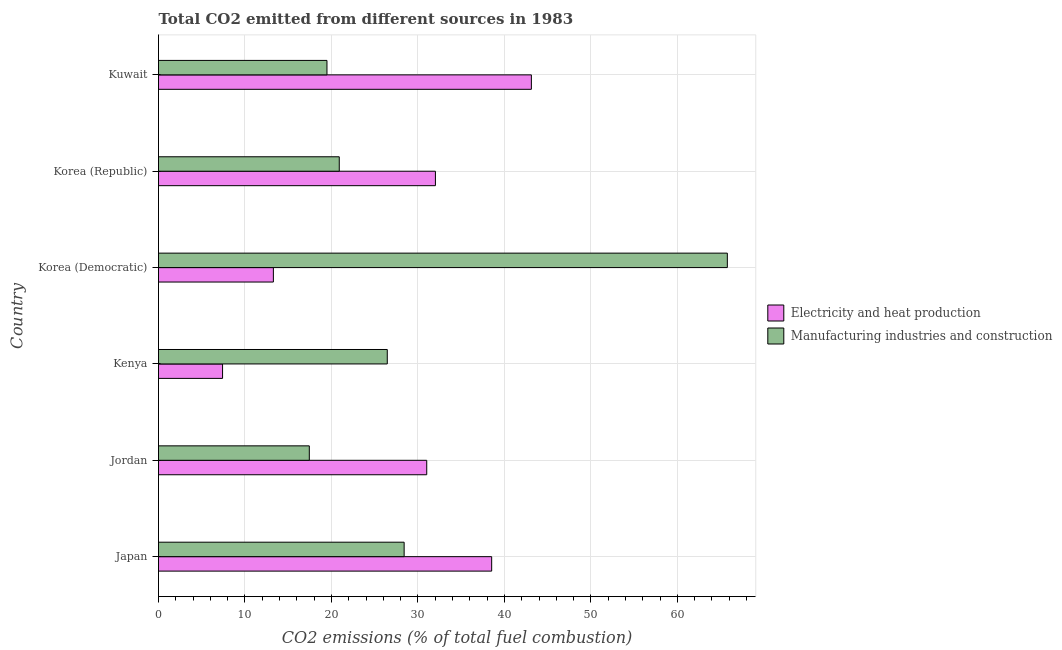Are the number of bars per tick equal to the number of legend labels?
Your response must be concise. Yes. Are the number of bars on each tick of the Y-axis equal?
Your answer should be compact. Yes. How many bars are there on the 5th tick from the top?
Your response must be concise. 2. What is the label of the 1st group of bars from the top?
Your response must be concise. Kuwait. In how many cases, is the number of bars for a given country not equal to the number of legend labels?
Offer a very short reply. 0. What is the co2 emissions due to manufacturing industries in Korea (Republic)?
Your answer should be compact. 20.9. Across all countries, what is the maximum co2 emissions due to electricity and heat production?
Your response must be concise. 43.12. Across all countries, what is the minimum co2 emissions due to electricity and heat production?
Your answer should be very brief. 7.41. In which country was the co2 emissions due to electricity and heat production maximum?
Your answer should be very brief. Kuwait. In which country was the co2 emissions due to electricity and heat production minimum?
Your response must be concise. Kenya. What is the total co2 emissions due to manufacturing industries in the graph?
Offer a very short reply. 178.46. What is the difference between the co2 emissions due to electricity and heat production in Jordan and that in Kuwait?
Your answer should be compact. -12.1. What is the difference between the co2 emissions due to electricity and heat production in Japan and the co2 emissions due to manufacturing industries in Korea (Democratic)?
Offer a very short reply. -27.25. What is the average co2 emissions due to electricity and heat production per country?
Provide a succinct answer. 27.56. What is the difference between the co2 emissions due to manufacturing industries and co2 emissions due to electricity and heat production in Korea (Republic)?
Make the answer very short. -11.12. What is the ratio of the co2 emissions due to electricity and heat production in Kenya to that in Korea (Republic)?
Provide a succinct answer. 0.23. Is the co2 emissions due to manufacturing industries in Korea (Republic) less than that in Kuwait?
Offer a terse response. No. Is the difference between the co2 emissions due to electricity and heat production in Japan and Kuwait greater than the difference between the co2 emissions due to manufacturing industries in Japan and Kuwait?
Offer a very short reply. No. What is the difference between the highest and the second highest co2 emissions due to manufacturing industries?
Offer a terse response. 37.38. What is the difference between the highest and the lowest co2 emissions due to manufacturing industries?
Give a very brief answer. 48.34. What does the 1st bar from the top in Kenya represents?
Your response must be concise. Manufacturing industries and construction. What does the 2nd bar from the bottom in Korea (Republic) represents?
Give a very brief answer. Manufacturing industries and construction. How many bars are there?
Your answer should be compact. 12. Are all the bars in the graph horizontal?
Provide a short and direct response. Yes. What is the difference between two consecutive major ticks on the X-axis?
Your answer should be very brief. 10. Are the values on the major ticks of X-axis written in scientific E-notation?
Your response must be concise. No. Where does the legend appear in the graph?
Your answer should be very brief. Center right. How many legend labels are there?
Your answer should be compact. 2. How are the legend labels stacked?
Offer a very short reply. Vertical. What is the title of the graph?
Provide a succinct answer. Total CO2 emitted from different sources in 1983. What is the label or title of the X-axis?
Your response must be concise. CO2 emissions (% of total fuel combustion). What is the CO2 emissions (% of total fuel combustion) of Electricity and heat production in Japan?
Keep it short and to the point. 38.53. What is the CO2 emissions (% of total fuel combustion) of Manufacturing industries and construction in Japan?
Your answer should be compact. 28.41. What is the CO2 emissions (% of total fuel combustion) in Electricity and heat production in Jordan?
Offer a terse response. 31.02. What is the CO2 emissions (% of total fuel combustion) in Manufacturing industries and construction in Jordan?
Offer a terse response. 17.44. What is the CO2 emissions (% of total fuel combustion) in Electricity and heat production in Kenya?
Make the answer very short. 7.41. What is the CO2 emissions (% of total fuel combustion) in Manufacturing industries and construction in Kenya?
Offer a terse response. 26.46. What is the CO2 emissions (% of total fuel combustion) in Electricity and heat production in Korea (Democratic)?
Make the answer very short. 13.28. What is the CO2 emissions (% of total fuel combustion) of Manufacturing industries and construction in Korea (Democratic)?
Provide a short and direct response. 65.78. What is the CO2 emissions (% of total fuel combustion) in Electricity and heat production in Korea (Republic)?
Provide a succinct answer. 32.02. What is the CO2 emissions (% of total fuel combustion) in Manufacturing industries and construction in Korea (Republic)?
Give a very brief answer. 20.9. What is the CO2 emissions (% of total fuel combustion) of Electricity and heat production in Kuwait?
Give a very brief answer. 43.12. What is the CO2 emissions (% of total fuel combustion) of Manufacturing industries and construction in Kuwait?
Keep it short and to the point. 19.48. Across all countries, what is the maximum CO2 emissions (% of total fuel combustion) in Electricity and heat production?
Provide a succinct answer. 43.12. Across all countries, what is the maximum CO2 emissions (% of total fuel combustion) of Manufacturing industries and construction?
Keep it short and to the point. 65.78. Across all countries, what is the minimum CO2 emissions (% of total fuel combustion) of Electricity and heat production?
Provide a succinct answer. 7.41. Across all countries, what is the minimum CO2 emissions (% of total fuel combustion) in Manufacturing industries and construction?
Your response must be concise. 17.44. What is the total CO2 emissions (% of total fuel combustion) in Electricity and heat production in the graph?
Your answer should be compact. 165.38. What is the total CO2 emissions (% of total fuel combustion) in Manufacturing industries and construction in the graph?
Provide a succinct answer. 178.46. What is the difference between the CO2 emissions (% of total fuel combustion) of Electricity and heat production in Japan and that in Jordan?
Your response must be concise. 7.51. What is the difference between the CO2 emissions (% of total fuel combustion) of Manufacturing industries and construction in Japan and that in Jordan?
Your response must be concise. 10.97. What is the difference between the CO2 emissions (% of total fuel combustion) of Electricity and heat production in Japan and that in Kenya?
Your answer should be compact. 31.12. What is the difference between the CO2 emissions (% of total fuel combustion) of Manufacturing industries and construction in Japan and that in Kenya?
Offer a terse response. 1.95. What is the difference between the CO2 emissions (% of total fuel combustion) in Electricity and heat production in Japan and that in Korea (Democratic)?
Your answer should be compact. 25.24. What is the difference between the CO2 emissions (% of total fuel combustion) in Manufacturing industries and construction in Japan and that in Korea (Democratic)?
Ensure brevity in your answer.  -37.38. What is the difference between the CO2 emissions (% of total fuel combustion) in Electricity and heat production in Japan and that in Korea (Republic)?
Ensure brevity in your answer.  6.51. What is the difference between the CO2 emissions (% of total fuel combustion) in Manufacturing industries and construction in Japan and that in Korea (Republic)?
Ensure brevity in your answer.  7.5. What is the difference between the CO2 emissions (% of total fuel combustion) of Electricity and heat production in Japan and that in Kuwait?
Give a very brief answer. -4.59. What is the difference between the CO2 emissions (% of total fuel combustion) of Manufacturing industries and construction in Japan and that in Kuwait?
Offer a very short reply. 8.93. What is the difference between the CO2 emissions (% of total fuel combustion) of Electricity and heat production in Jordan and that in Kenya?
Provide a short and direct response. 23.61. What is the difference between the CO2 emissions (% of total fuel combustion) of Manufacturing industries and construction in Jordan and that in Kenya?
Your response must be concise. -9.02. What is the difference between the CO2 emissions (% of total fuel combustion) of Electricity and heat production in Jordan and that in Korea (Democratic)?
Ensure brevity in your answer.  17.74. What is the difference between the CO2 emissions (% of total fuel combustion) of Manufacturing industries and construction in Jordan and that in Korea (Democratic)?
Offer a very short reply. -48.34. What is the difference between the CO2 emissions (% of total fuel combustion) in Electricity and heat production in Jordan and that in Korea (Republic)?
Your answer should be compact. -1. What is the difference between the CO2 emissions (% of total fuel combustion) of Manufacturing industries and construction in Jordan and that in Korea (Republic)?
Provide a succinct answer. -3.46. What is the difference between the CO2 emissions (% of total fuel combustion) of Electricity and heat production in Jordan and that in Kuwait?
Provide a short and direct response. -12.1. What is the difference between the CO2 emissions (% of total fuel combustion) of Manufacturing industries and construction in Jordan and that in Kuwait?
Ensure brevity in your answer.  -2.04. What is the difference between the CO2 emissions (% of total fuel combustion) in Electricity and heat production in Kenya and that in Korea (Democratic)?
Offer a very short reply. -5.88. What is the difference between the CO2 emissions (% of total fuel combustion) of Manufacturing industries and construction in Kenya and that in Korea (Democratic)?
Your response must be concise. -39.33. What is the difference between the CO2 emissions (% of total fuel combustion) of Electricity and heat production in Kenya and that in Korea (Republic)?
Your answer should be compact. -24.61. What is the difference between the CO2 emissions (% of total fuel combustion) in Manufacturing industries and construction in Kenya and that in Korea (Republic)?
Your answer should be compact. 5.55. What is the difference between the CO2 emissions (% of total fuel combustion) in Electricity and heat production in Kenya and that in Kuwait?
Offer a terse response. -35.71. What is the difference between the CO2 emissions (% of total fuel combustion) in Manufacturing industries and construction in Kenya and that in Kuwait?
Give a very brief answer. 6.97. What is the difference between the CO2 emissions (% of total fuel combustion) of Electricity and heat production in Korea (Democratic) and that in Korea (Republic)?
Ensure brevity in your answer.  -18.74. What is the difference between the CO2 emissions (% of total fuel combustion) of Manufacturing industries and construction in Korea (Democratic) and that in Korea (Republic)?
Your answer should be compact. 44.88. What is the difference between the CO2 emissions (% of total fuel combustion) in Electricity and heat production in Korea (Democratic) and that in Kuwait?
Ensure brevity in your answer.  -29.84. What is the difference between the CO2 emissions (% of total fuel combustion) in Manufacturing industries and construction in Korea (Democratic) and that in Kuwait?
Your answer should be compact. 46.3. What is the difference between the CO2 emissions (% of total fuel combustion) in Electricity and heat production in Korea (Republic) and that in Kuwait?
Make the answer very short. -11.1. What is the difference between the CO2 emissions (% of total fuel combustion) of Manufacturing industries and construction in Korea (Republic) and that in Kuwait?
Offer a very short reply. 1.42. What is the difference between the CO2 emissions (% of total fuel combustion) of Electricity and heat production in Japan and the CO2 emissions (% of total fuel combustion) of Manufacturing industries and construction in Jordan?
Provide a short and direct response. 21.09. What is the difference between the CO2 emissions (% of total fuel combustion) of Electricity and heat production in Japan and the CO2 emissions (% of total fuel combustion) of Manufacturing industries and construction in Kenya?
Keep it short and to the point. 12.07. What is the difference between the CO2 emissions (% of total fuel combustion) of Electricity and heat production in Japan and the CO2 emissions (% of total fuel combustion) of Manufacturing industries and construction in Korea (Democratic)?
Provide a short and direct response. -27.25. What is the difference between the CO2 emissions (% of total fuel combustion) in Electricity and heat production in Japan and the CO2 emissions (% of total fuel combustion) in Manufacturing industries and construction in Korea (Republic)?
Your response must be concise. 17.63. What is the difference between the CO2 emissions (% of total fuel combustion) of Electricity and heat production in Japan and the CO2 emissions (% of total fuel combustion) of Manufacturing industries and construction in Kuwait?
Your response must be concise. 19.05. What is the difference between the CO2 emissions (% of total fuel combustion) of Electricity and heat production in Jordan and the CO2 emissions (% of total fuel combustion) of Manufacturing industries and construction in Kenya?
Give a very brief answer. 4.56. What is the difference between the CO2 emissions (% of total fuel combustion) of Electricity and heat production in Jordan and the CO2 emissions (% of total fuel combustion) of Manufacturing industries and construction in Korea (Democratic)?
Your answer should be compact. -34.76. What is the difference between the CO2 emissions (% of total fuel combustion) of Electricity and heat production in Jordan and the CO2 emissions (% of total fuel combustion) of Manufacturing industries and construction in Korea (Republic)?
Offer a very short reply. 10.12. What is the difference between the CO2 emissions (% of total fuel combustion) of Electricity and heat production in Jordan and the CO2 emissions (% of total fuel combustion) of Manufacturing industries and construction in Kuwait?
Keep it short and to the point. 11.54. What is the difference between the CO2 emissions (% of total fuel combustion) of Electricity and heat production in Kenya and the CO2 emissions (% of total fuel combustion) of Manufacturing industries and construction in Korea (Democratic)?
Offer a terse response. -58.37. What is the difference between the CO2 emissions (% of total fuel combustion) of Electricity and heat production in Kenya and the CO2 emissions (% of total fuel combustion) of Manufacturing industries and construction in Korea (Republic)?
Keep it short and to the point. -13.49. What is the difference between the CO2 emissions (% of total fuel combustion) in Electricity and heat production in Kenya and the CO2 emissions (% of total fuel combustion) in Manufacturing industries and construction in Kuwait?
Provide a short and direct response. -12.07. What is the difference between the CO2 emissions (% of total fuel combustion) of Electricity and heat production in Korea (Democratic) and the CO2 emissions (% of total fuel combustion) of Manufacturing industries and construction in Korea (Republic)?
Your answer should be very brief. -7.62. What is the difference between the CO2 emissions (% of total fuel combustion) in Electricity and heat production in Korea (Democratic) and the CO2 emissions (% of total fuel combustion) in Manufacturing industries and construction in Kuwait?
Provide a short and direct response. -6.2. What is the difference between the CO2 emissions (% of total fuel combustion) in Electricity and heat production in Korea (Republic) and the CO2 emissions (% of total fuel combustion) in Manufacturing industries and construction in Kuwait?
Make the answer very short. 12.54. What is the average CO2 emissions (% of total fuel combustion) of Electricity and heat production per country?
Your answer should be very brief. 27.56. What is the average CO2 emissions (% of total fuel combustion) of Manufacturing industries and construction per country?
Give a very brief answer. 29.74. What is the difference between the CO2 emissions (% of total fuel combustion) in Electricity and heat production and CO2 emissions (% of total fuel combustion) in Manufacturing industries and construction in Japan?
Offer a very short reply. 10.12. What is the difference between the CO2 emissions (% of total fuel combustion) in Electricity and heat production and CO2 emissions (% of total fuel combustion) in Manufacturing industries and construction in Jordan?
Your answer should be compact. 13.58. What is the difference between the CO2 emissions (% of total fuel combustion) of Electricity and heat production and CO2 emissions (% of total fuel combustion) of Manufacturing industries and construction in Kenya?
Ensure brevity in your answer.  -19.05. What is the difference between the CO2 emissions (% of total fuel combustion) in Electricity and heat production and CO2 emissions (% of total fuel combustion) in Manufacturing industries and construction in Korea (Democratic)?
Offer a terse response. -52.5. What is the difference between the CO2 emissions (% of total fuel combustion) of Electricity and heat production and CO2 emissions (% of total fuel combustion) of Manufacturing industries and construction in Korea (Republic)?
Keep it short and to the point. 11.12. What is the difference between the CO2 emissions (% of total fuel combustion) in Electricity and heat production and CO2 emissions (% of total fuel combustion) in Manufacturing industries and construction in Kuwait?
Provide a succinct answer. 23.64. What is the ratio of the CO2 emissions (% of total fuel combustion) of Electricity and heat production in Japan to that in Jordan?
Your answer should be very brief. 1.24. What is the ratio of the CO2 emissions (% of total fuel combustion) of Manufacturing industries and construction in Japan to that in Jordan?
Ensure brevity in your answer.  1.63. What is the ratio of the CO2 emissions (% of total fuel combustion) of Electricity and heat production in Japan to that in Kenya?
Offer a terse response. 5.2. What is the ratio of the CO2 emissions (% of total fuel combustion) of Manufacturing industries and construction in Japan to that in Kenya?
Your answer should be very brief. 1.07. What is the ratio of the CO2 emissions (% of total fuel combustion) in Electricity and heat production in Japan to that in Korea (Democratic)?
Provide a short and direct response. 2.9. What is the ratio of the CO2 emissions (% of total fuel combustion) of Manufacturing industries and construction in Japan to that in Korea (Democratic)?
Keep it short and to the point. 0.43. What is the ratio of the CO2 emissions (% of total fuel combustion) in Electricity and heat production in Japan to that in Korea (Republic)?
Provide a succinct answer. 1.2. What is the ratio of the CO2 emissions (% of total fuel combustion) in Manufacturing industries and construction in Japan to that in Korea (Republic)?
Your answer should be compact. 1.36. What is the ratio of the CO2 emissions (% of total fuel combustion) of Electricity and heat production in Japan to that in Kuwait?
Provide a succinct answer. 0.89. What is the ratio of the CO2 emissions (% of total fuel combustion) of Manufacturing industries and construction in Japan to that in Kuwait?
Your answer should be very brief. 1.46. What is the ratio of the CO2 emissions (% of total fuel combustion) of Electricity and heat production in Jordan to that in Kenya?
Keep it short and to the point. 4.19. What is the ratio of the CO2 emissions (% of total fuel combustion) in Manufacturing industries and construction in Jordan to that in Kenya?
Your response must be concise. 0.66. What is the ratio of the CO2 emissions (% of total fuel combustion) in Electricity and heat production in Jordan to that in Korea (Democratic)?
Your answer should be very brief. 2.34. What is the ratio of the CO2 emissions (% of total fuel combustion) of Manufacturing industries and construction in Jordan to that in Korea (Democratic)?
Keep it short and to the point. 0.27. What is the ratio of the CO2 emissions (% of total fuel combustion) of Electricity and heat production in Jordan to that in Korea (Republic)?
Provide a short and direct response. 0.97. What is the ratio of the CO2 emissions (% of total fuel combustion) in Manufacturing industries and construction in Jordan to that in Korea (Republic)?
Ensure brevity in your answer.  0.83. What is the ratio of the CO2 emissions (% of total fuel combustion) in Electricity and heat production in Jordan to that in Kuwait?
Your answer should be very brief. 0.72. What is the ratio of the CO2 emissions (% of total fuel combustion) in Manufacturing industries and construction in Jordan to that in Kuwait?
Your response must be concise. 0.9. What is the ratio of the CO2 emissions (% of total fuel combustion) of Electricity and heat production in Kenya to that in Korea (Democratic)?
Give a very brief answer. 0.56. What is the ratio of the CO2 emissions (% of total fuel combustion) in Manufacturing industries and construction in Kenya to that in Korea (Democratic)?
Your answer should be very brief. 0.4. What is the ratio of the CO2 emissions (% of total fuel combustion) of Electricity and heat production in Kenya to that in Korea (Republic)?
Your answer should be compact. 0.23. What is the ratio of the CO2 emissions (% of total fuel combustion) in Manufacturing industries and construction in Kenya to that in Korea (Republic)?
Provide a short and direct response. 1.27. What is the ratio of the CO2 emissions (% of total fuel combustion) in Electricity and heat production in Kenya to that in Kuwait?
Keep it short and to the point. 0.17. What is the ratio of the CO2 emissions (% of total fuel combustion) of Manufacturing industries and construction in Kenya to that in Kuwait?
Give a very brief answer. 1.36. What is the ratio of the CO2 emissions (% of total fuel combustion) in Electricity and heat production in Korea (Democratic) to that in Korea (Republic)?
Offer a very short reply. 0.41. What is the ratio of the CO2 emissions (% of total fuel combustion) of Manufacturing industries and construction in Korea (Democratic) to that in Korea (Republic)?
Your answer should be very brief. 3.15. What is the ratio of the CO2 emissions (% of total fuel combustion) of Electricity and heat production in Korea (Democratic) to that in Kuwait?
Provide a short and direct response. 0.31. What is the ratio of the CO2 emissions (% of total fuel combustion) of Manufacturing industries and construction in Korea (Democratic) to that in Kuwait?
Give a very brief answer. 3.38. What is the ratio of the CO2 emissions (% of total fuel combustion) in Electricity and heat production in Korea (Republic) to that in Kuwait?
Your answer should be compact. 0.74. What is the ratio of the CO2 emissions (% of total fuel combustion) of Manufacturing industries and construction in Korea (Republic) to that in Kuwait?
Your answer should be compact. 1.07. What is the difference between the highest and the second highest CO2 emissions (% of total fuel combustion) of Electricity and heat production?
Your answer should be very brief. 4.59. What is the difference between the highest and the second highest CO2 emissions (% of total fuel combustion) of Manufacturing industries and construction?
Provide a short and direct response. 37.38. What is the difference between the highest and the lowest CO2 emissions (% of total fuel combustion) in Electricity and heat production?
Offer a terse response. 35.71. What is the difference between the highest and the lowest CO2 emissions (% of total fuel combustion) in Manufacturing industries and construction?
Your response must be concise. 48.34. 